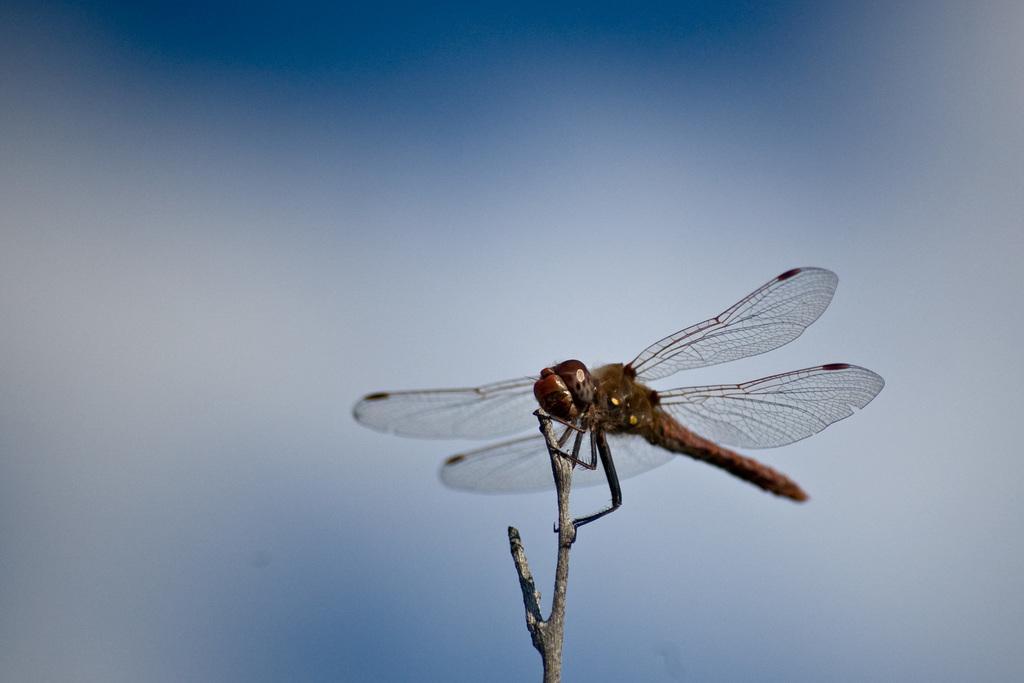Could you give a brief overview of what you see in this image? On the right side, there is an insect having wings and legs and standing on a branch of a tree. And the background is blue in color. 